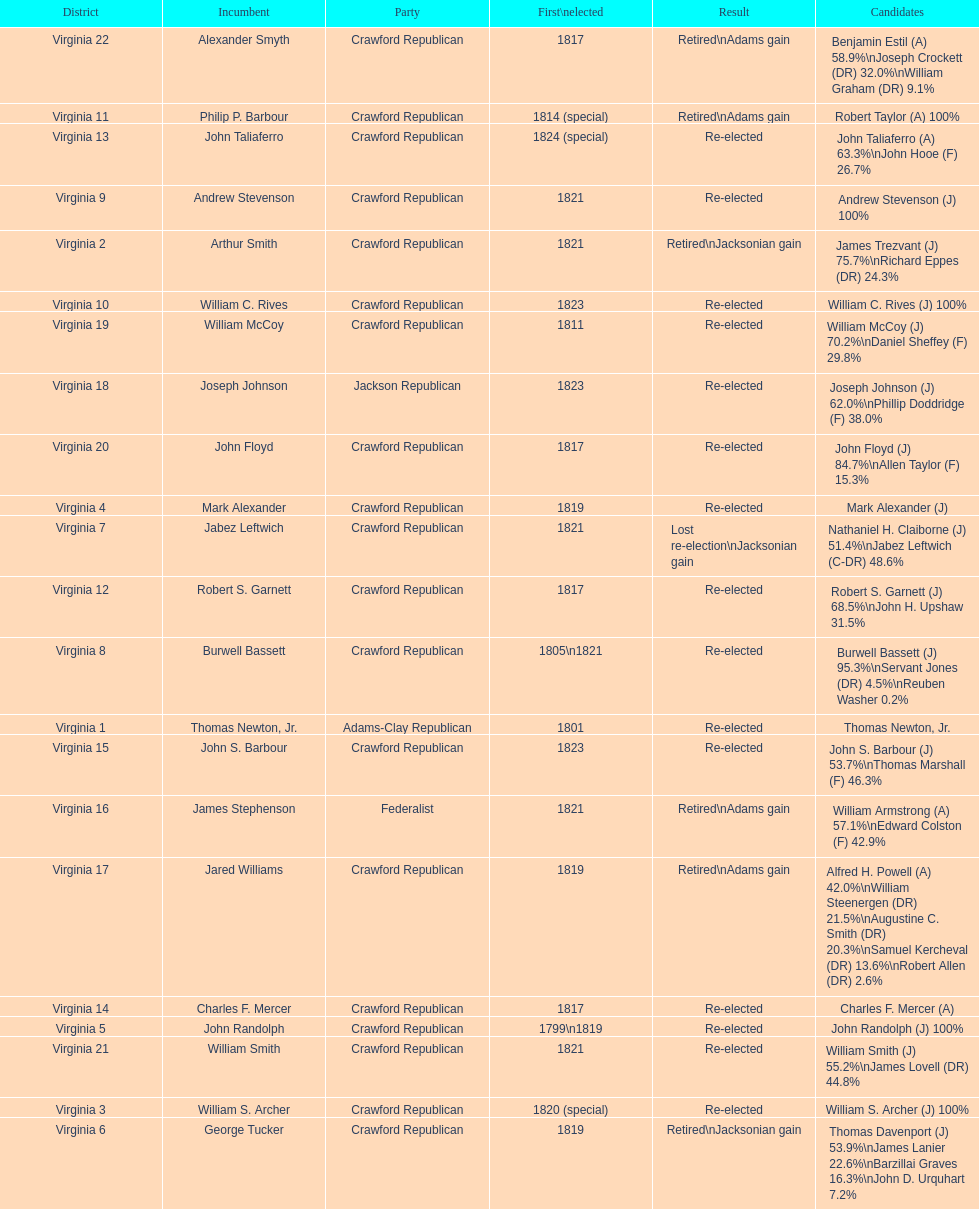Number of incumbents who retired or lost re-election 7. 